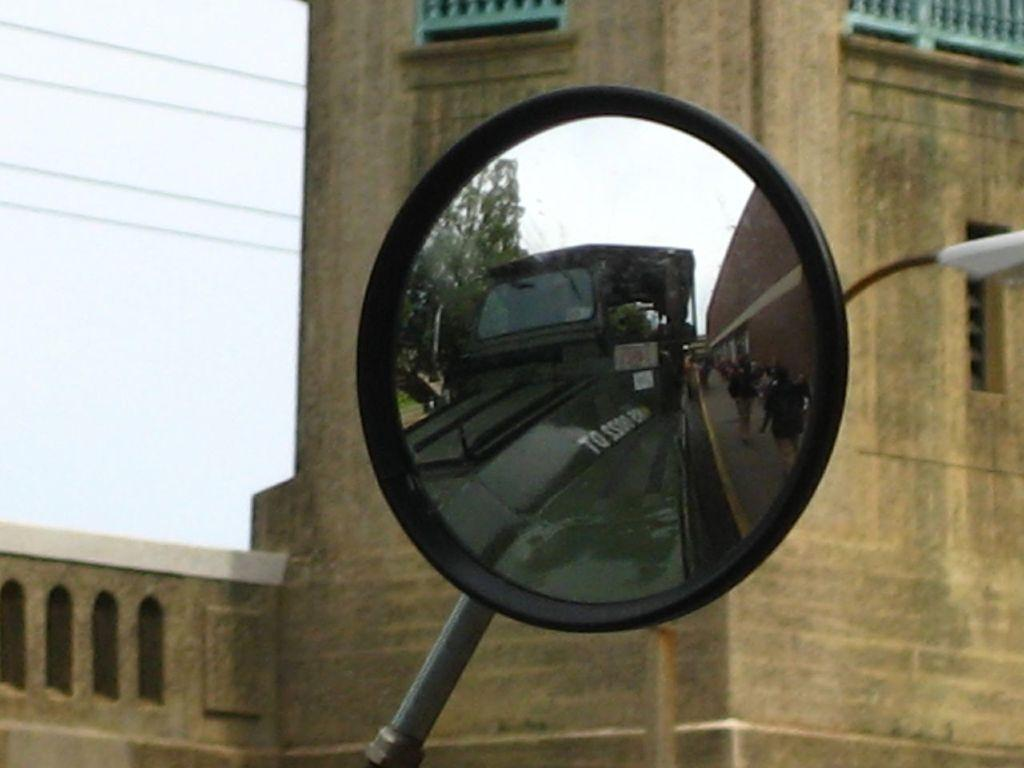What is the main subject of the image? The main subject of the image is a vehicle side mirror. What can be seen through the side mirror? Through the side mirror, a vehicle, people, a wall, trees, and the sky are visible. What is visible in the background of the image? In the background of the image, there is a building, wires, a light, and the sky. Can you tell me how many rats are holding onto the hope in the image? There are no rats or any indication of hope present in the image. What type of grip does the vehicle have on the wall in the image? The image does not show the vehicle having any grip on the wall; it only shows the vehicle side mirror. 